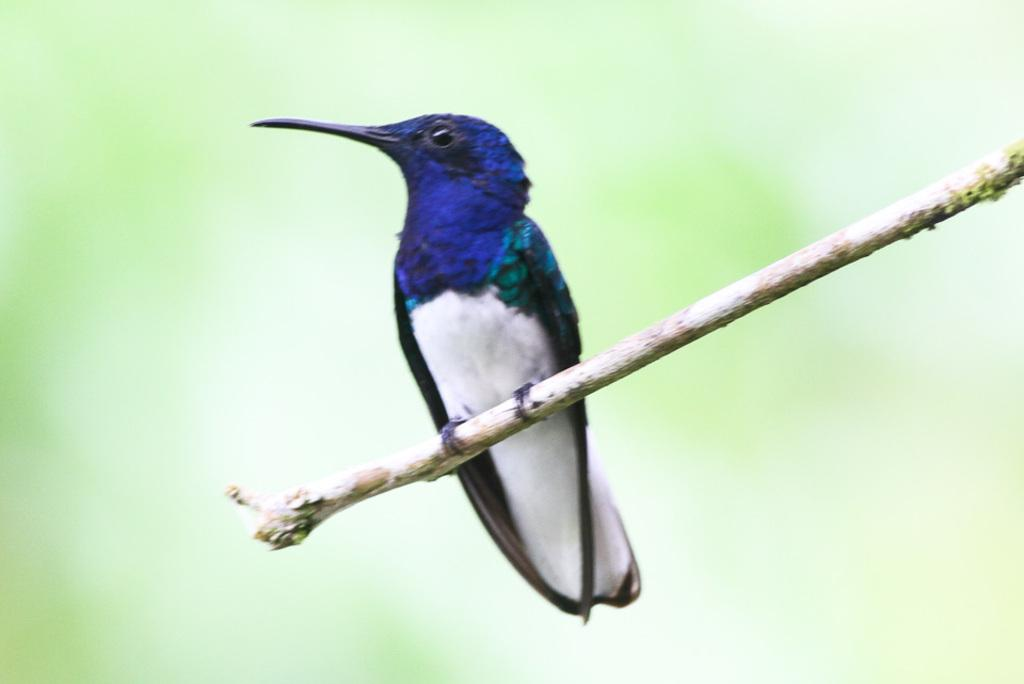What type of bird can be seen in the image? There is a blue color bird in the image. Where is the bird located? The bird is on a branch. Can you describe the background of the image? The background of the image is blurred. What type of disease is the bird suffering from in the image? There is no indication in the image that the bird is suffering from any disease. 